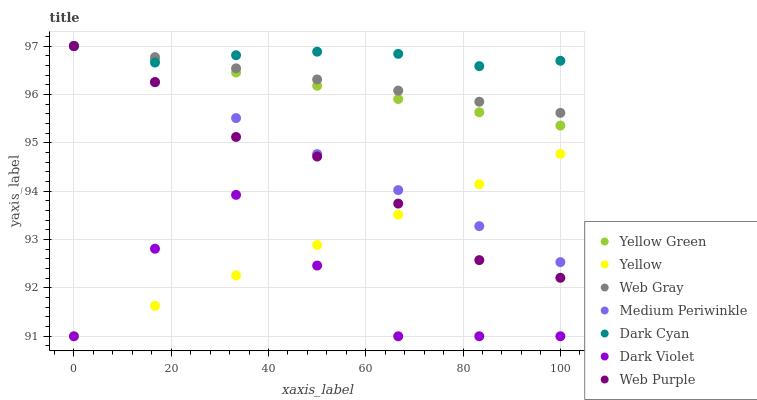Does Dark Violet have the minimum area under the curve?
Answer yes or no. Yes. Does Dark Cyan have the maximum area under the curve?
Answer yes or no. Yes. Does Yellow Green have the minimum area under the curve?
Answer yes or no. No. Does Yellow Green have the maximum area under the curve?
Answer yes or no. No. Is Yellow the smoothest?
Answer yes or no. Yes. Is Dark Violet the roughest?
Answer yes or no. Yes. Is Yellow Green the smoothest?
Answer yes or no. No. Is Yellow Green the roughest?
Answer yes or no. No. Does Dark Violet have the lowest value?
Answer yes or no. Yes. Does Yellow Green have the lowest value?
Answer yes or no. No. Does Dark Cyan have the highest value?
Answer yes or no. Yes. Does Dark Violet have the highest value?
Answer yes or no. No. Is Dark Violet less than Web Purple?
Answer yes or no. Yes. Is Web Purple greater than Dark Violet?
Answer yes or no. Yes. Does Yellow intersect Web Purple?
Answer yes or no. Yes. Is Yellow less than Web Purple?
Answer yes or no. No. Is Yellow greater than Web Purple?
Answer yes or no. No. Does Dark Violet intersect Web Purple?
Answer yes or no. No. 